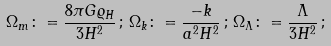Convert formula to latex. <formula><loc_0><loc_0><loc_500><loc_500>\Omega _ { m } \colon = \frac { 8 \pi G \varrho _ { H } } { 3 H ^ { 2 } } \, ; \, \Omega _ { k } \colon = \frac { - k } { a ^ { 2 } H ^ { 2 } } \, ; \, \Omega _ { \Lambda } \colon = \frac { \Lambda } { 3 H ^ { 2 } } \, ;</formula> 